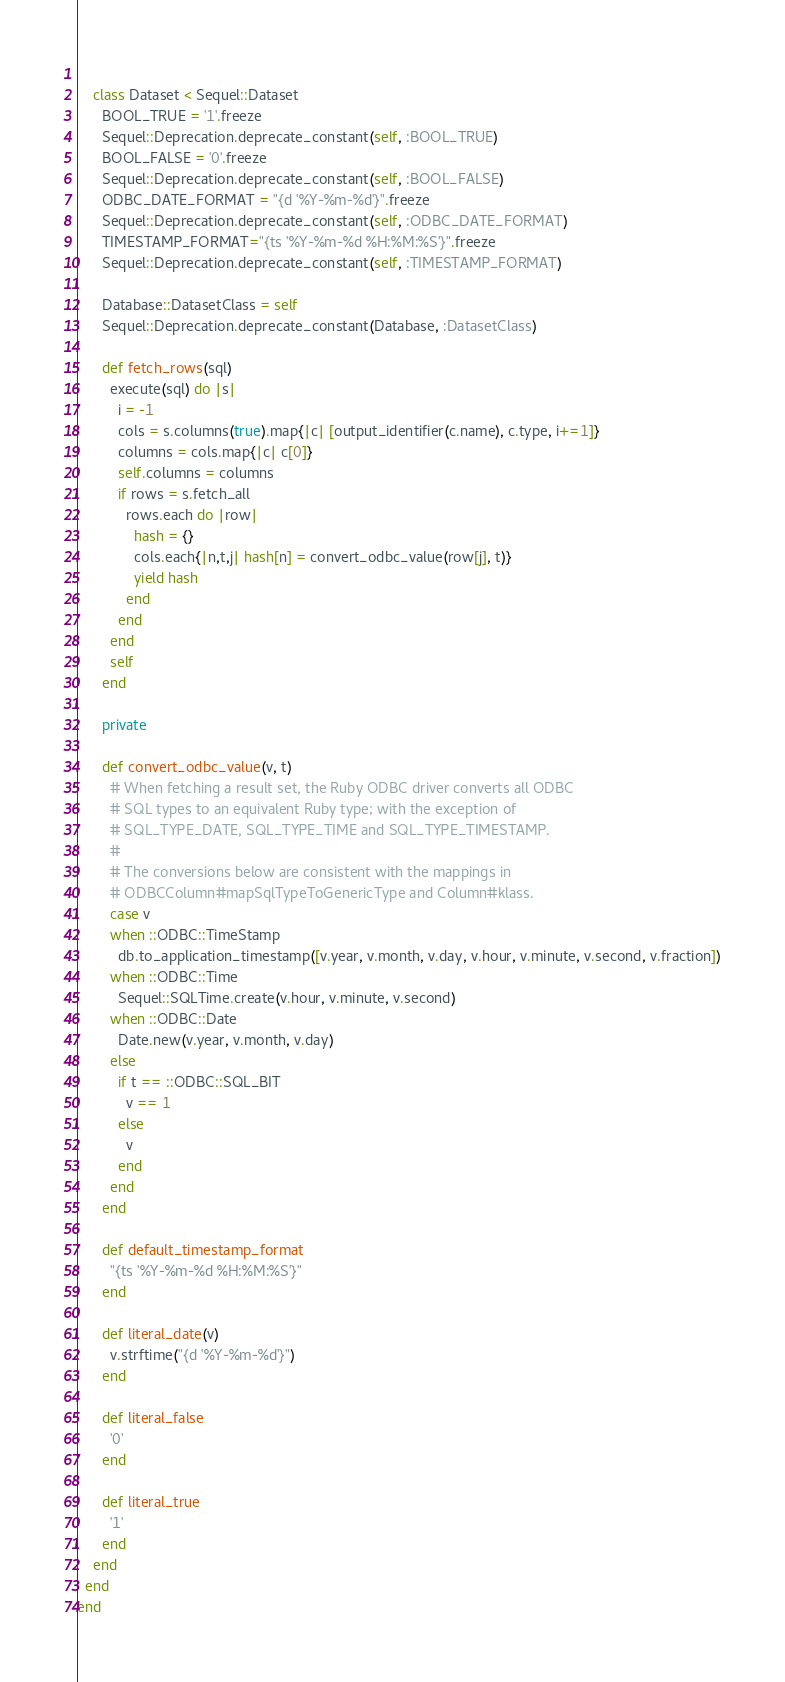<code> <loc_0><loc_0><loc_500><loc_500><_Ruby_>    
    class Dataset < Sequel::Dataset
      BOOL_TRUE = '1'.freeze
      Sequel::Deprecation.deprecate_constant(self, :BOOL_TRUE)
      BOOL_FALSE = '0'.freeze
      Sequel::Deprecation.deprecate_constant(self, :BOOL_FALSE)
      ODBC_DATE_FORMAT = "{d '%Y-%m-%d'}".freeze
      Sequel::Deprecation.deprecate_constant(self, :ODBC_DATE_FORMAT)
      TIMESTAMP_FORMAT="{ts '%Y-%m-%d %H:%M:%S'}".freeze
      Sequel::Deprecation.deprecate_constant(self, :TIMESTAMP_FORMAT)

      Database::DatasetClass = self
      Sequel::Deprecation.deprecate_constant(Database, :DatasetClass)

      def fetch_rows(sql)
        execute(sql) do |s|
          i = -1
          cols = s.columns(true).map{|c| [output_identifier(c.name), c.type, i+=1]}
          columns = cols.map{|c| c[0]}
          self.columns = columns
          if rows = s.fetch_all
            rows.each do |row|
              hash = {}
              cols.each{|n,t,j| hash[n] = convert_odbc_value(row[j], t)}
              yield hash
            end
          end
        end
        self
      end
      
      private

      def convert_odbc_value(v, t)
        # When fetching a result set, the Ruby ODBC driver converts all ODBC 
        # SQL types to an equivalent Ruby type; with the exception of
        # SQL_TYPE_DATE, SQL_TYPE_TIME and SQL_TYPE_TIMESTAMP.
        #
        # The conversions below are consistent with the mappings in
        # ODBCColumn#mapSqlTypeToGenericType and Column#klass.
        case v
        when ::ODBC::TimeStamp
          db.to_application_timestamp([v.year, v.month, v.day, v.hour, v.minute, v.second, v.fraction])
        when ::ODBC::Time
          Sequel::SQLTime.create(v.hour, v.minute, v.second)
        when ::ODBC::Date
          Date.new(v.year, v.month, v.day)
        else
          if t == ::ODBC::SQL_BIT
            v == 1
          else
            v
          end
        end
      end
      
      def default_timestamp_format
        "{ts '%Y-%m-%d %H:%M:%S'}"
      end

      def literal_date(v)
        v.strftime("{d '%Y-%m-%d'}")
      end
      
      def literal_false
        '0'
      end
      
      def literal_true
        '1'
      end
    end
  end
end
</code> 